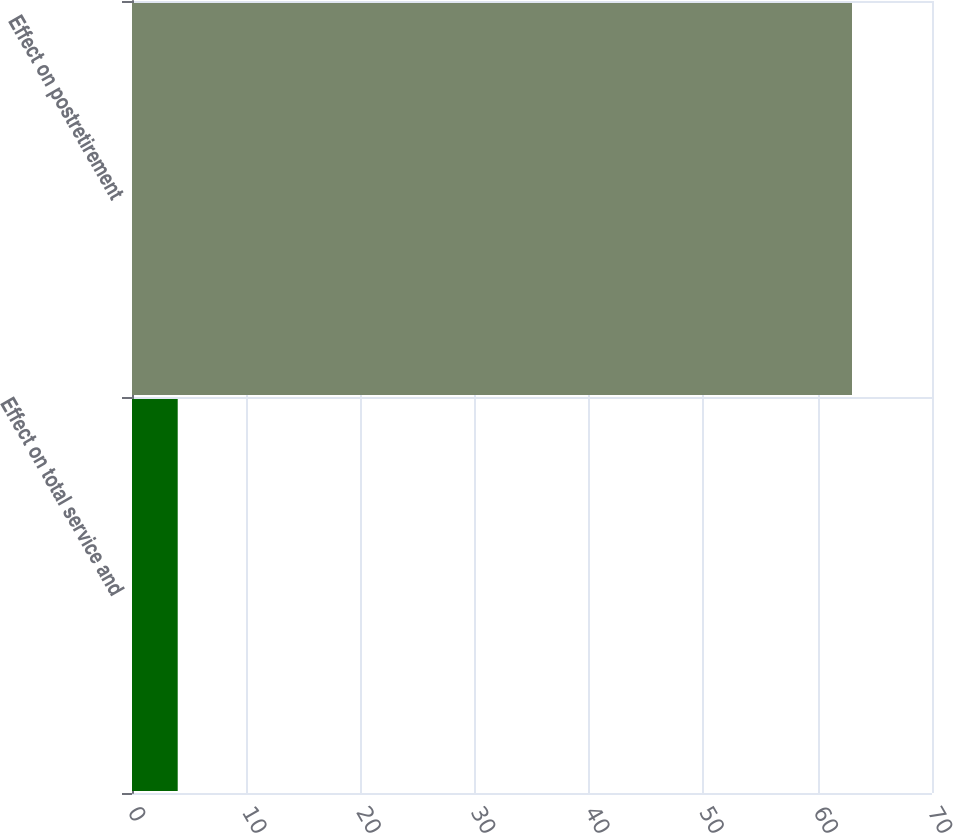<chart> <loc_0><loc_0><loc_500><loc_500><bar_chart><fcel>Effect on total service and<fcel>Effect on postretirement<nl><fcel>4<fcel>63<nl></chart> 